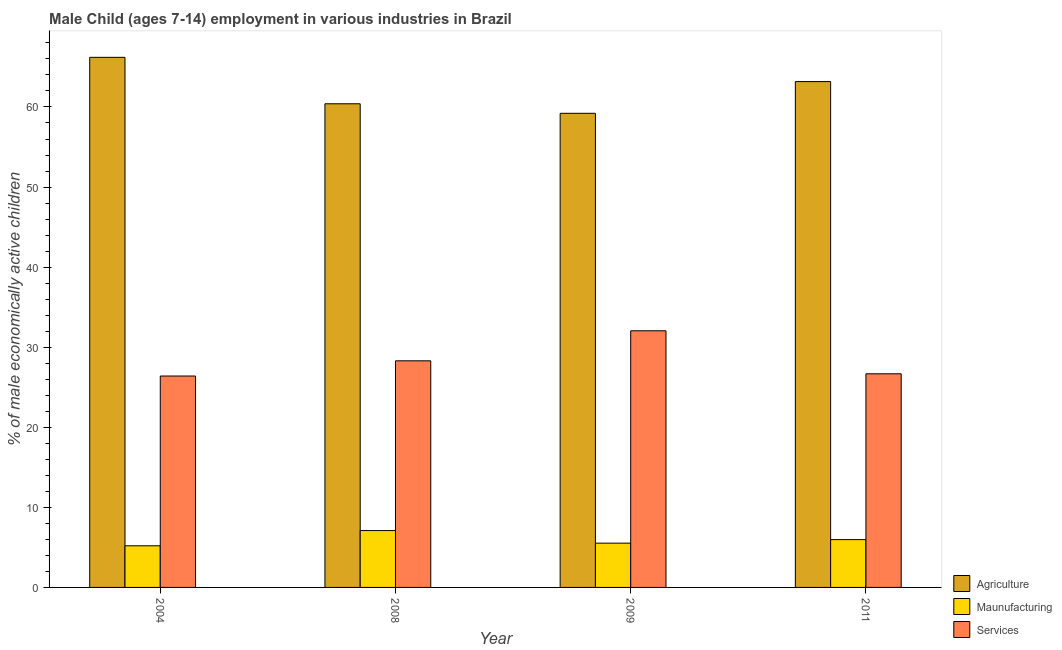How many different coloured bars are there?
Your response must be concise. 3. Are the number of bars on each tick of the X-axis equal?
Keep it short and to the point. Yes. How many bars are there on the 1st tick from the right?
Give a very brief answer. 3. What is the percentage of economically active children in manufacturing in 2008?
Keep it short and to the point. 7.1. Across all years, what is the maximum percentage of economically active children in agriculture?
Your answer should be compact. 66.2. Across all years, what is the minimum percentage of economically active children in manufacturing?
Offer a very short reply. 5.2. In which year was the percentage of economically active children in manufacturing maximum?
Your answer should be compact. 2008. What is the total percentage of economically active children in agriculture in the graph?
Your response must be concise. 248.98. What is the difference between the percentage of economically active children in services in 2008 and that in 2011?
Your answer should be very brief. 1.62. What is the difference between the percentage of economically active children in agriculture in 2004 and the percentage of economically active children in services in 2009?
Offer a terse response. 6.99. What is the average percentage of economically active children in services per year?
Your answer should be compact. 28.36. In how many years, is the percentage of economically active children in agriculture greater than 28 %?
Offer a very short reply. 4. What is the ratio of the percentage of economically active children in services in 2008 to that in 2009?
Ensure brevity in your answer.  0.88. What is the difference between the highest and the second highest percentage of economically active children in agriculture?
Offer a very short reply. 3.03. What is the difference between the highest and the lowest percentage of economically active children in services?
Your answer should be very brief. 5.65. Is the sum of the percentage of economically active children in agriculture in 2004 and 2009 greater than the maximum percentage of economically active children in services across all years?
Ensure brevity in your answer.  Yes. What does the 1st bar from the left in 2011 represents?
Ensure brevity in your answer.  Agriculture. What does the 1st bar from the right in 2011 represents?
Make the answer very short. Services. How many bars are there?
Your response must be concise. 12. Are all the bars in the graph horizontal?
Provide a short and direct response. No. How many years are there in the graph?
Keep it short and to the point. 4. Does the graph contain any zero values?
Offer a very short reply. No. Does the graph contain grids?
Provide a short and direct response. No. How many legend labels are there?
Make the answer very short. 3. How are the legend labels stacked?
Provide a short and direct response. Vertical. What is the title of the graph?
Offer a very short reply. Male Child (ages 7-14) employment in various industries in Brazil. What is the label or title of the X-axis?
Provide a short and direct response. Year. What is the label or title of the Y-axis?
Provide a short and direct response. % of male economically active children. What is the % of male economically active children in Agriculture in 2004?
Offer a terse response. 66.2. What is the % of male economically active children in Services in 2004?
Ensure brevity in your answer.  26.4. What is the % of male economically active children in Agriculture in 2008?
Make the answer very short. 60.4. What is the % of male economically active children in Maunufacturing in 2008?
Ensure brevity in your answer.  7.1. What is the % of male economically active children of Services in 2008?
Provide a succinct answer. 28.3. What is the % of male economically active children of Agriculture in 2009?
Provide a short and direct response. 59.21. What is the % of male economically active children of Maunufacturing in 2009?
Make the answer very short. 5.53. What is the % of male economically active children in Services in 2009?
Offer a very short reply. 32.05. What is the % of male economically active children in Agriculture in 2011?
Offer a terse response. 63.17. What is the % of male economically active children in Maunufacturing in 2011?
Your answer should be compact. 5.97. What is the % of male economically active children of Services in 2011?
Give a very brief answer. 26.68. Across all years, what is the maximum % of male economically active children in Agriculture?
Your answer should be compact. 66.2. Across all years, what is the maximum % of male economically active children in Maunufacturing?
Make the answer very short. 7.1. Across all years, what is the maximum % of male economically active children in Services?
Make the answer very short. 32.05. Across all years, what is the minimum % of male economically active children in Agriculture?
Make the answer very short. 59.21. Across all years, what is the minimum % of male economically active children in Maunufacturing?
Your answer should be very brief. 5.2. Across all years, what is the minimum % of male economically active children of Services?
Make the answer very short. 26.4. What is the total % of male economically active children of Agriculture in the graph?
Offer a very short reply. 248.98. What is the total % of male economically active children in Maunufacturing in the graph?
Keep it short and to the point. 23.8. What is the total % of male economically active children of Services in the graph?
Keep it short and to the point. 113.43. What is the difference between the % of male economically active children of Maunufacturing in 2004 and that in 2008?
Make the answer very short. -1.9. What is the difference between the % of male economically active children in Agriculture in 2004 and that in 2009?
Make the answer very short. 6.99. What is the difference between the % of male economically active children in Maunufacturing in 2004 and that in 2009?
Your response must be concise. -0.33. What is the difference between the % of male economically active children of Services in 2004 and that in 2009?
Offer a very short reply. -5.65. What is the difference between the % of male economically active children in Agriculture in 2004 and that in 2011?
Make the answer very short. 3.03. What is the difference between the % of male economically active children of Maunufacturing in 2004 and that in 2011?
Your answer should be very brief. -0.77. What is the difference between the % of male economically active children of Services in 2004 and that in 2011?
Make the answer very short. -0.28. What is the difference between the % of male economically active children in Agriculture in 2008 and that in 2009?
Your answer should be very brief. 1.19. What is the difference between the % of male economically active children of Maunufacturing in 2008 and that in 2009?
Keep it short and to the point. 1.57. What is the difference between the % of male economically active children in Services in 2008 and that in 2009?
Your response must be concise. -3.75. What is the difference between the % of male economically active children of Agriculture in 2008 and that in 2011?
Provide a short and direct response. -2.77. What is the difference between the % of male economically active children of Maunufacturing in 2008 and that in 2011?
Ensure brevity in your answer.  1.13. What is the difference between the % of male economically active children of Services in 2008 and that in 2011?
Offer a very short reply. 1.62. What is the difference between the % of male economically active children in Agriculture in 2009 and that in 2011?
Give a very brief answer. -3.96. What is the difference between the % of male economically active children of Maunufacturing in 2009 and that in 2011?
Ensure brevity in your answer.  -0.44. What is the difference between the % of male economically active children in Services in 2009 and that in 2011?
Give a very brief answer. 5.37. What is the difference between the % of male economically active children of Agriculture in 2004 and the % of male economically active children of Maunufacturing in 2008?
Give a very brief answer. 59.1. What is the difference between the % of male economically active children in Agriculture in 2004 and the % of male economically active children in Services in 2008?
Ensure brevity in your answer.  37.9. What is the difference between the % of male economically active children in Maunufacturing in 2004 and the % of male economically active children in Services in 2008?
Make the answer very short. -23.1. What is the difference between the % of male economically active children in Agriculture in 2004 and the % of male economically active children in Maunufacturing in 2009?
Your answer should be very brief. 60.67. What is the difference between the % of male economically active children of Agriculture in 2004 and the % of male economically active children of Services in 2009?
Your answer should be compact. 34.15. What is the difference between the % of male economically active children in Maunufacturing in 2004 and the % of male economically active children in Services in 2009?
Offer a very short reply. -26.85. What is the difference between the % of male economically active children of Agriculture in 2004 and the % of male economically active children of Maunufacturing in 2011?
Ensure brevity in your answer.  60.23. What is the difference between the % of male economically active children of Agriculture in 2004 and the % of male economically active children of Services in 2011?
Your answer should be very brief. 39.52. What is the difference between the % of male economically active children in Maunufacturing in 2004 and the % of male economically active children in Services in 2011?
Keep it short and to the point. -21.48. What is the difference between the % of male economically active children in Agriculture in 2008 and the % of male economically active children in Maunufacturing in 2009?
Offer a very short reply. 54.87. What is the difference between the % of male economically active children in Agriculture in 2008 and the % of male economically active children in Services in 2009?
Give a very brief answer. 28.35. What is the difference between the % of male economically active children in Maunufacturing in 2008 and the % of male economically active children in Services in 2009?
Make the answer very short. -24.95. What is the difference between the % of male economically active children in Agriculture in 2008 and the % of male economically active children in Maunufacturing in 2011?
Your answer should be compact. 54.43. What is the difference between the % of male economically active children of Agriculture in 2008 and the % of male economically active children of Services in 2011?
Your answer should be compact. 33.72. What is the difference between the % of male economically active children in Maunufacturing in 2008 and the % of male economically active children in Services in 2011?
Provide a succinct answer. -19.58. What is the difference between the % of male economically active children of Agriculture in 2009 and the % of male economically active children of Maunufacturing in 2011?
Make the answer very short. 53.24. What is the difference between the % of male economically active children in Agriculture in 2009 and the % of male economically active children in Services in 2011?
Offer a very short reply. 32.53. What is the difference between the % of male economically active children in Maunufacturing in 2009 and the % of male economically active children in Services in 2011?
Provide a succinct answer. -21.15. What is the average % of male economically active children of Agriculture per year?
Offer a terse response. 62.24. What is the average % of male economically active children of Maunufacturing per year?
Provide a short and direct response. 5.95. What is the average % of male economically active children in Services per year?
Your answer should be compact. 28.36. In the year 2004, what is the difference between the % of male economically active children in Agriculture and % of male economically active children in Maunufacturing?
Ensure brevity in your answer.  61. In the year 2004, what is the difference between the % of male economically active children in Agriculture and % of male economically active children in Services?
Offer a terse response. 39.8. In the year 2004, what is the difference between the % of male economically active children in Maunufacturing and % of male economically active children in Services?
Your answer should be compact. -21.2. In the year 2008, what is the difference between the % of male economically active children of Agriculture and % of male economically active children of Maunufacturing?
Make the answer very short. 53.3. In the year 2008, what is the difference between the % of male economically active children of Agriculture and % of male economically active children of Services?
Keep it short and to the point. 32.1. In the year 2008, what is the difference between the % of male economically active children of Maunufacturing and % of male economically active children of Services?
Offer a very short reply. -21.2. In the year 2009, what is the difference between the % of male economically active children in Agriculture and % of male economically active children in Maunufacturing?
Offer a very short reply. 53.68. In the year 2009, what is the difference between the % of male economically active children in Agriculture and % of male economically active children in Services?
Make the answer very short. 27.16. In the year 2009, what is the difference between the % of male economically active children in Maunufacturing and % of male economically active children in Services?
Offer a terse response. -26.52. In the year 2011, what is the difference between the % of male economically active children of Agriculture and % of male economically active children of Maunufacturing?
Your response must be concise. 57.2. In the year 2011, what is the difference between the % of male economically active children in Agriculture and % of male economically active children in Services?
Offer a very short reply. 36.49. In the year 2011, what is the difference between the % of male economically active children of Maunufacturing and % of male economically active children of Services?
Your response must be concise. -20.71. What is the ratio of the % of male economically active children of Agriculture in 2004 to that in 2008?
Your answer should be very brief. 1.1. What is the ratio of the % of male economically active children in Maunufacturing in 2004 to that in 2008?
Your answer should be compact. 0.73. What is the ratio of the % of male economically active children of Services in 2004 to that in 2008?
Give a very brief answer. 0.93. What is the ratio of the % of male economically active children of Agriculture in 2004 to that in 2009?
Your answer should be compact. 1.12. What is the ratio of the % of male economically active children in Maunufacturing in 2004 to that in 2009?
Provide a short and direct response. 0.94. What is the ratio of the % of male economically active children in Services in 2004 to that in 2009?
Your answer should be very brief. 0.82. What is the ratio of the % of male economically active children in Agriculture in 2004 to that in 2011?
Give a very brief answer. 1.05. What is the ratio of the % of male economically active children of Maunufacturing in 2004 to that in 2011?
Provide a short and direct response. 0.87. What is the ratio of the % of male economically active children of Services in 2004 to that in 2011?
Ensure brevity in your answer.  0.99. What is the ratio of the % of male economically active children in Agriculture in 2008 to that in 2009?
Your response must be concise. 1.02. What is the ratio of the % of male economically active children in Maunufacturing in 2008 to that in 2009?
Provide a succinct answer. 1.28. What is the ratio of the % of male economically active children in Services in 2008 to that in 2009?
Give a very brief answer. 0.88. What is the ratio of the % of male economically active children in Agriculture in 2008 to that in 2011?
Your answer should be compact. 0.96. What is the ratio of the % of male economically active children of Maunufacturing in 2008 to that in 2011?
Give a very brief answer. 1.19. What is the ratio of the % of male economically active children of Services in 2008 to that in 2011?
Offer a very short reply. 1.06. What is the ratio of the % of male economically active children of Agriculture in 2009 to that in 2011?
Offer a very short reply. 0.94. What is the ratio of the % of male economically active children in Maunufacturing in 2009 to that in 2011?
Give a very brief answer. 0.93. What is the ratio of the % of male economically active children of Services in 2009 to that in 2011?
Your answer should be compact. 1.2. What is the difference between the highest and the second highest % of male economically active children in Agriculture?
Offer a terse response. 3.03. What is the difference between the highest and the second highest % of male economically active children of Maunufacturing?
Provide a succinct answer. 1.13. What is the difference between the highest and the second highest % of male economically active children in Services?
Provide a succinct answer. 3.75. What is the difference between the highest and the lowest % of male economically active children in Agriculture?
Your answer should be compact. 6.99. What is the difference between the highest and the lowest % of male economically active children of Maunufacturing?
Provide a short and direct response. 1.9. What is the difference between the highest and the lowest % of male economically active children of Services?
Give a very brief answer. 5.65. 